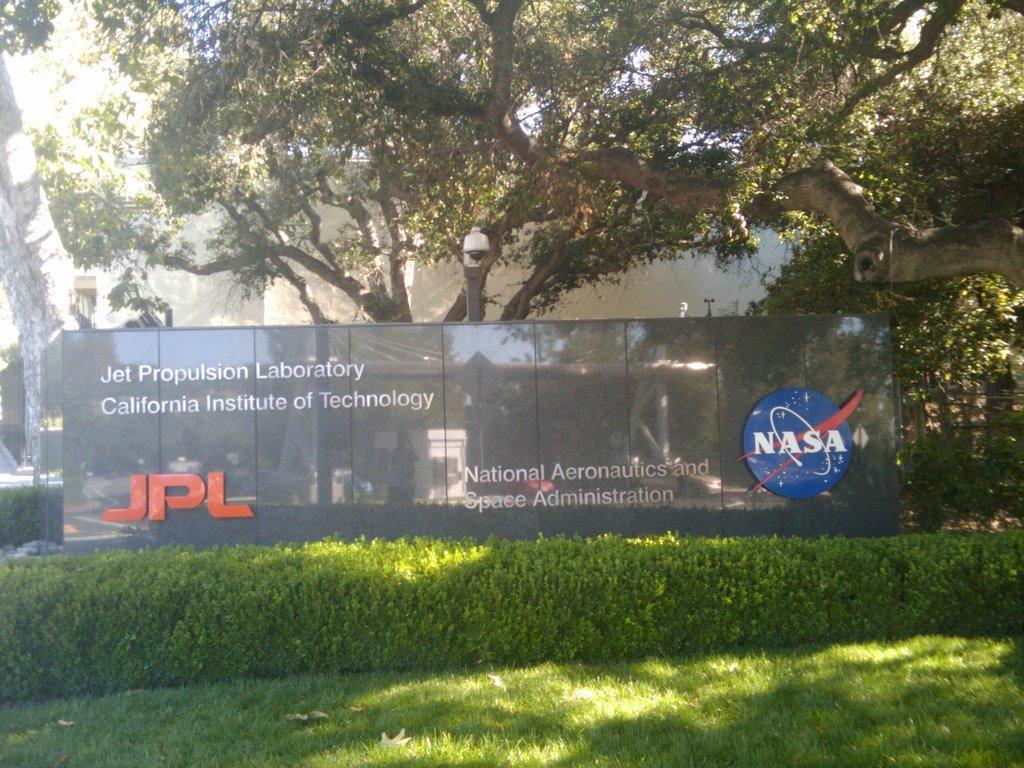Could you give a brief overview of what you see in this image? In the bottom of the image there is grass. In the background of the image there is a building. There are trees. 